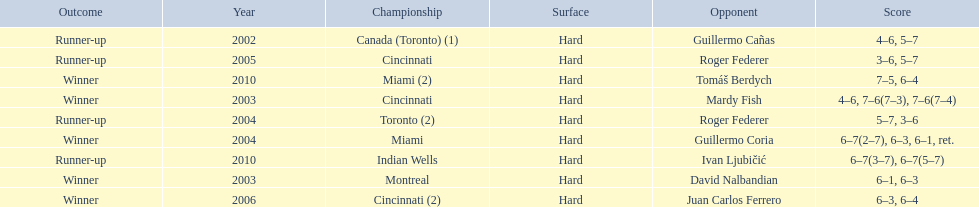How many times has he been runner-up? 4. 